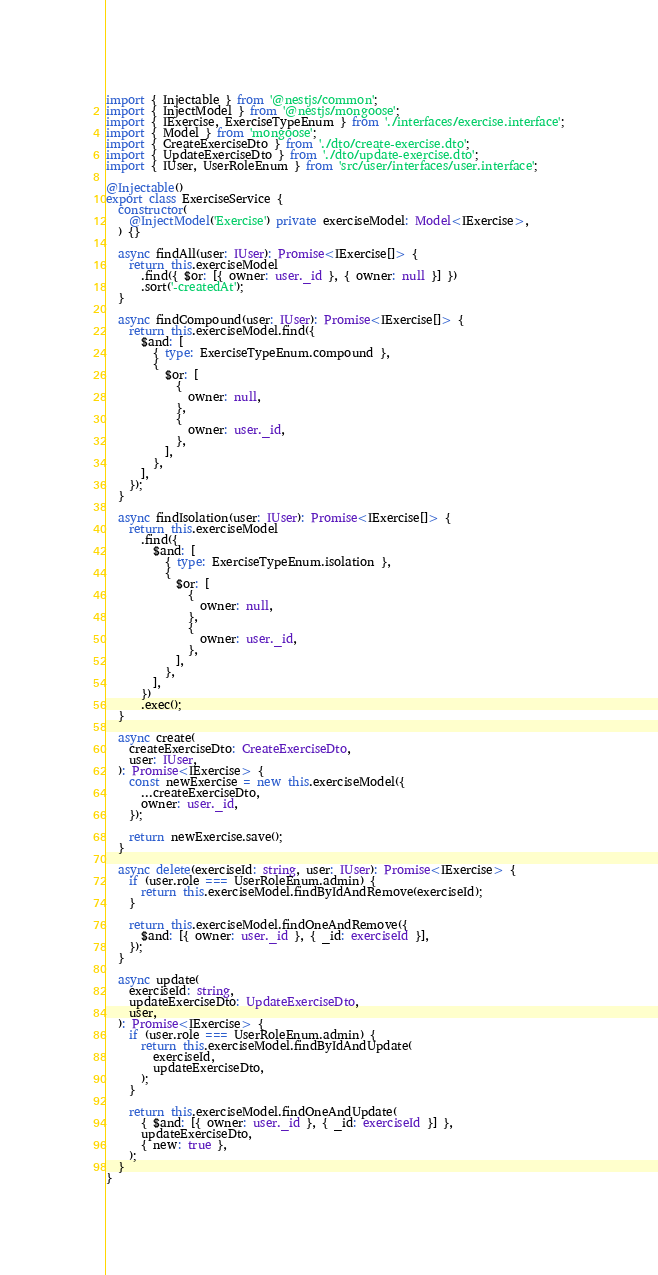<code> <loc_0><loc_0><loc_500><loc_500><_TypeScript_>import { Injectable } from '@nestjs/common';
import { InjectModel } from '@nestjs/mongoose';
import { IExercise, ExerciseTypeEnum } from './interfaces/exercise.interface';
import { Model } from 'mongoose';
import { CreateExerciseDto } from './dto/create-exercise.dto';
import { UpdateExerciseDto } from './dto/update-exercise.dto';
import { IUser, UserRoleEnum } from 'src/user/interfaces/user.interface';

@Injectable()
export class ExerciseService {
  constructor(
    @InjectModel('Exercise') private exerciseModel: Model<IExercise>,
  ) {}

  async findAll(user: IUser): Promise<IExercise[]> {
    return this.exerciseModel
      .find({ $or: [{ owner: user._id }, { owner: null }] })
      .sort('-createdAt');
  }

  async findCompound(user: IUser): Promise<IExercise[]> {
    return this.exerciseModel.find({
      $and: [
        { type: ExerciseTypeEnum.compound },
        {
          $or: [
            {
              owner: null,
            },
            {
              owner: user._id,
            },
          ],
        },
      ],
    });
  }

  async findIsolation(user: IUser): Promise<IExercise[]> {
    return this.exerciseModel
      .find({
        $and: [
          { type: ExerciseTypeEnum.isolation },
          {
            $or: [
              {
                owner: null,
              },
              {
                owner: user._id,
              },
            ],
          },
        ],
      })
      .exec();
  }

  async create(
    createExerciseDto: CreateExerciseDto,
    user: IUser,
  ): Promise<IExercise> {
    const newExercise = new this.exerciseModel({
      ...createExerciseDto,
      owner: user._id,
    });

    return newExercise.save();
  }

  async delete(exerciseId: string, user: IUser): Promise<IExercise> {
    if (user.role === UserRoleEnum.admin) {
      return this.exerciseModel.findByIdAndRemove(exerciseId);
    }

    return this.exerciseModel.findOneAndRemove({
      $and: [{ owner: user._id }, { _id: exerciseId }],
    });
  }

  async update(
    exerciseId: string,
    updateExerciseDto: UpdateExerciseDto,
    user,
  ): Promise<IExercise> {
    if (user.role === UserRoleEnum.admin) {
      return this.exerciseModel.findByIdAndUpdate(
        exerciseId,
        updateExerciseDto,
      );
    }

    return this.exerciseModel.findOneAndUpdate(
      { $and: [{ owner: user._id }, { _id: exerciseId }] },
      updateExerciseDto,
      { new: true },
    );
  }
}
</code> 